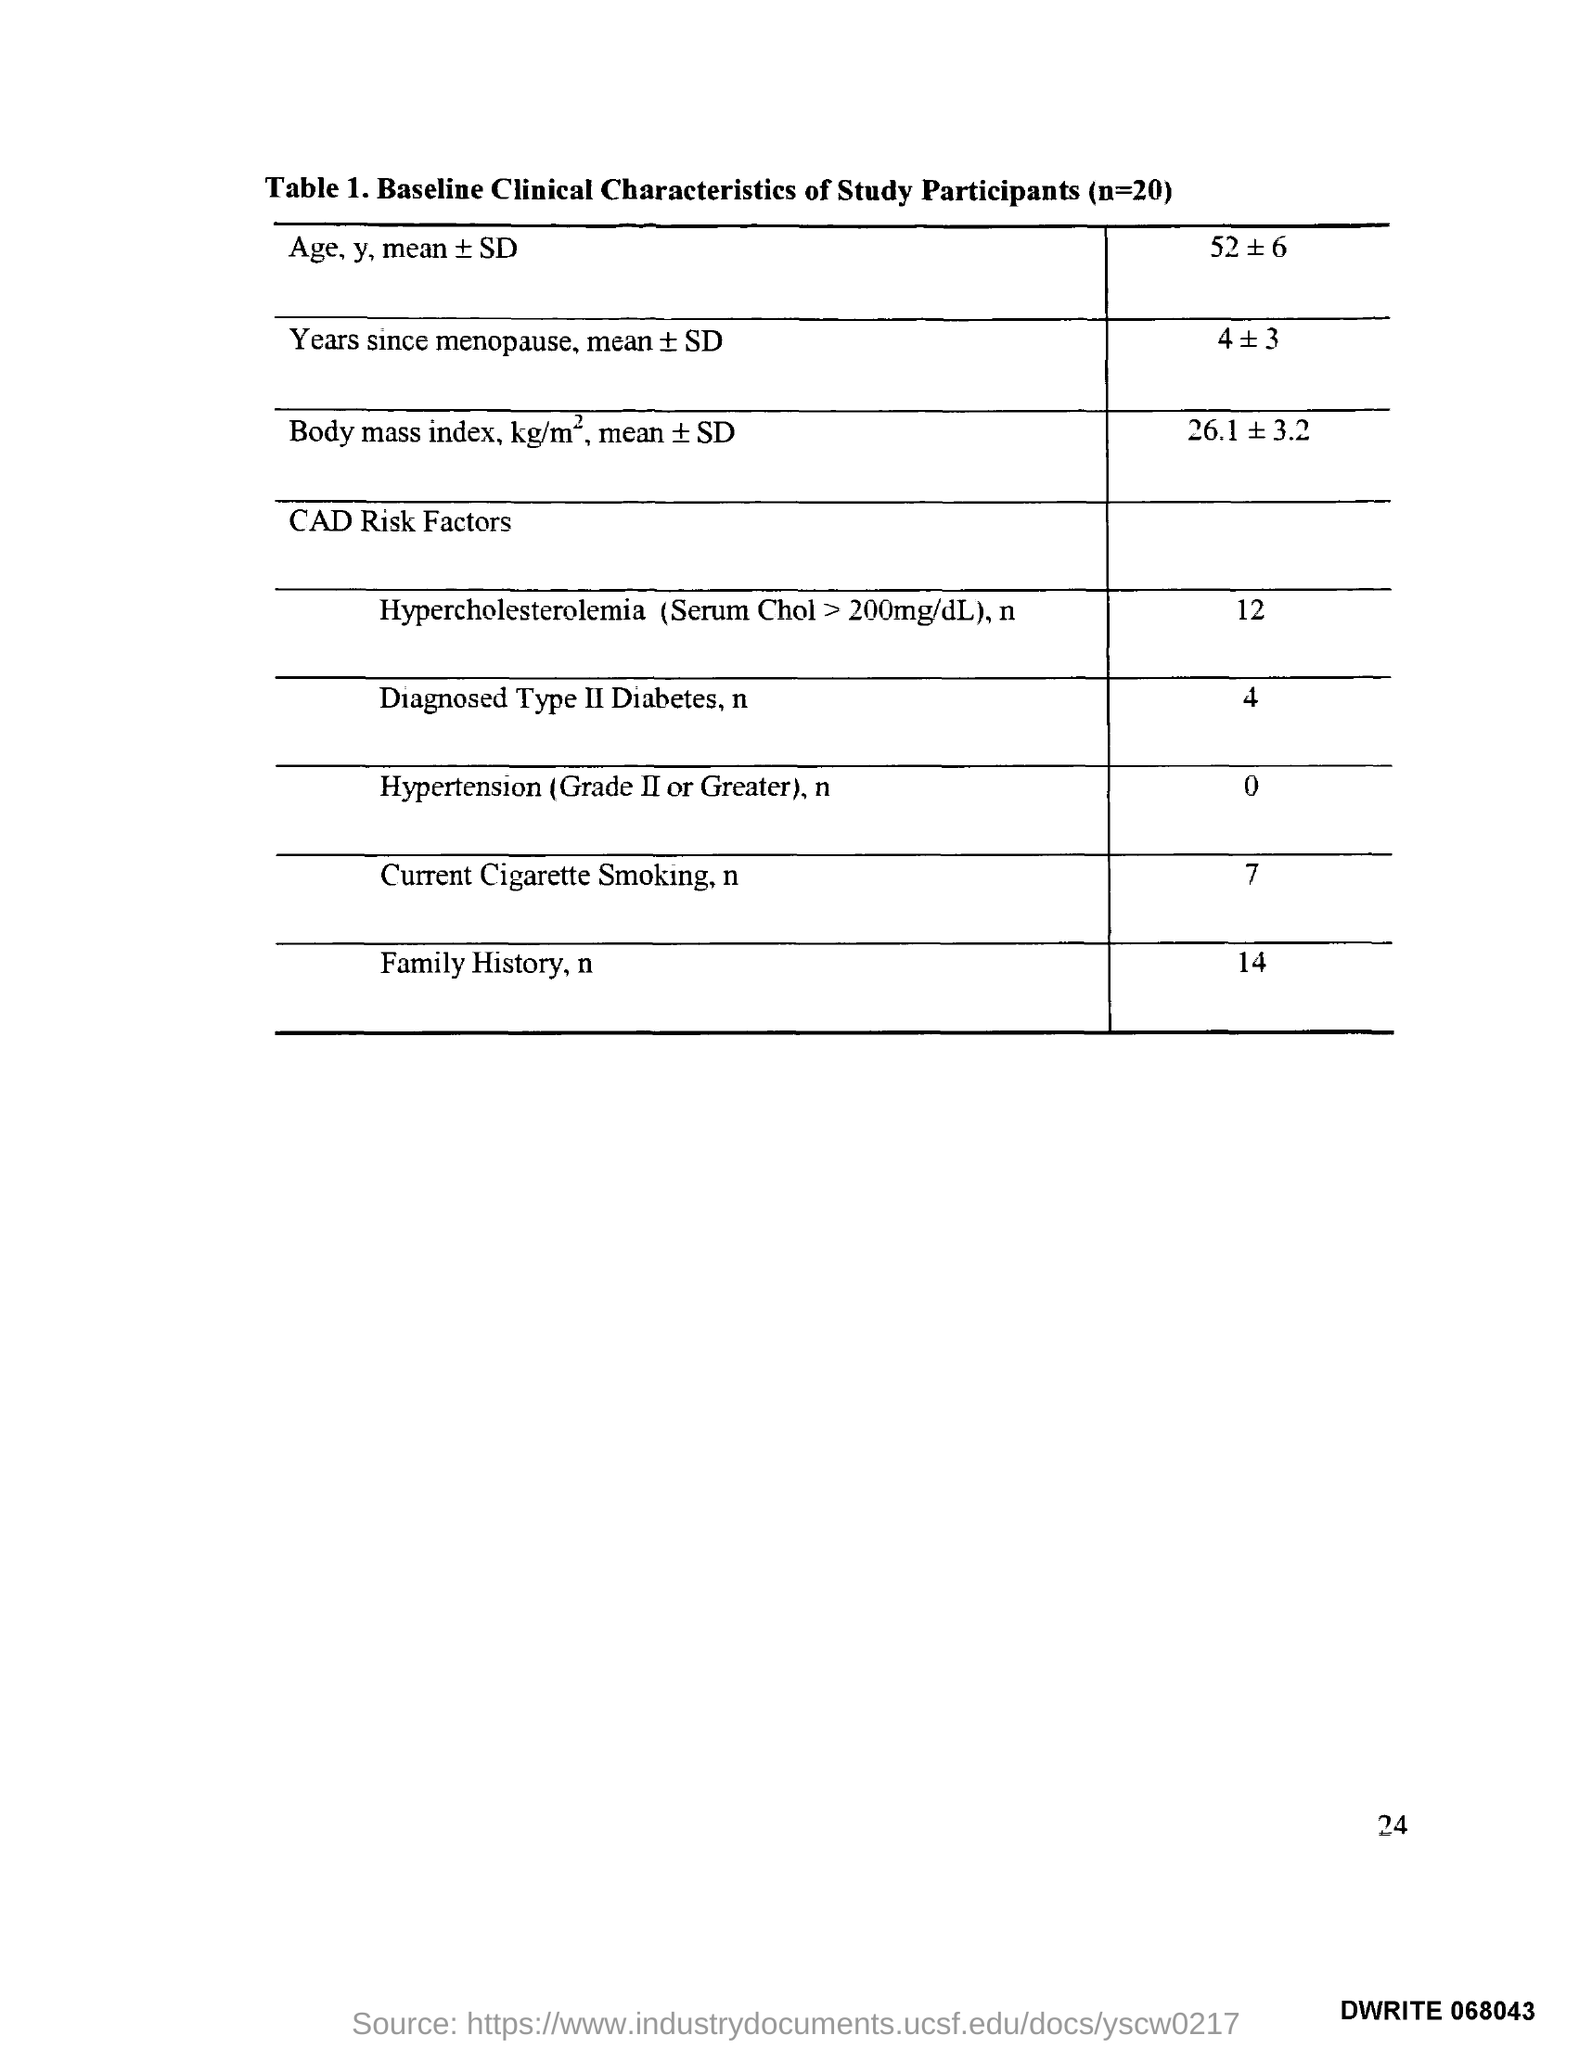List a handful of essential elements in this visual. Table 1 in this document provides a description of the baseline clinical characteristics of the study participants. 